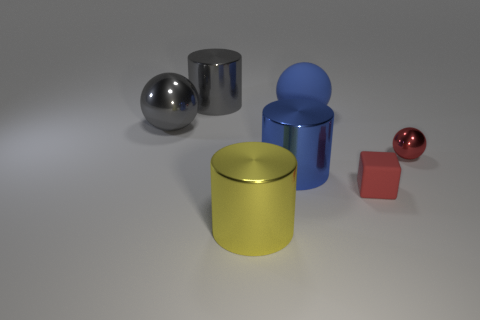Does the big object on the left side of the large gray cylinder have the same material as the small red cube?
Offer a terse response. No. What color is the big rubber thing that is the same shape as the red shiny object?
Provide a succinct answer. Blue. How many other things are there of the same color as the tiny shiny thing?
Offer a very short reply. 1. There is a blue thing right of the large blue cylinder; is its shape the same as the gray thing that is behind the large blue matte thing?
Provide a short and direct response. No. How many cylinders are either large blue objects or rubber things?
Your response must be concise. 1. Are there fewer big blue rubber spheres right of the rubber block than tiny green matte spheres?
Your response must be concise. No. How many other things are the same material as the block?
Ensure brevity in your answer.  1. Does the red rubber cube have the same size as the red shiny sphere?
Give a very brief answer. Yes. How many things are either large gray metal objects that are behind the big gray metal sphere or large brown matte cylinders?
Make the answer very short. 1. The large object right of the cylinder to the right of the large yellow shiny object is made of what material?
Make the answer very short. Rubber. 